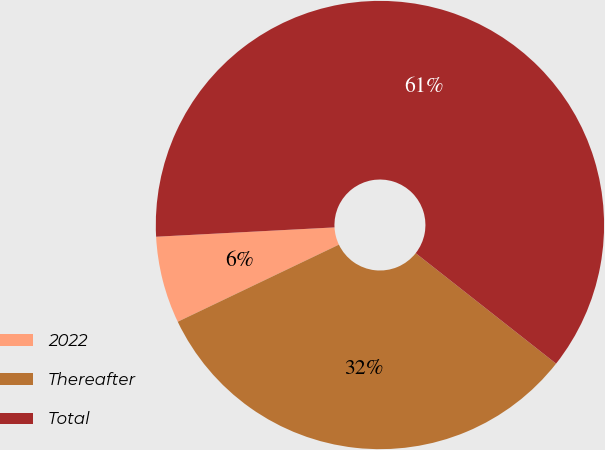Convert chart to OTSL. <chart><loc_0><loc_0><loc_500><loc_500><pie_chart><fcel>2022<fcel>Thereafter<fcel>Total<nl><fcel>6.27%<fcel>32.29%<fcel>61.45%<nl></chart> 